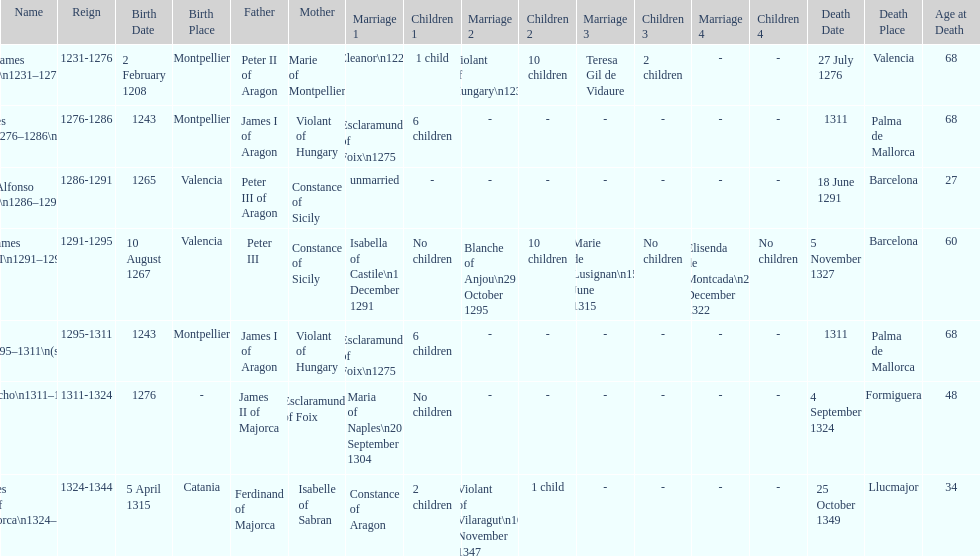Which two monarchs had no children? Alfonso I, Sancho. 